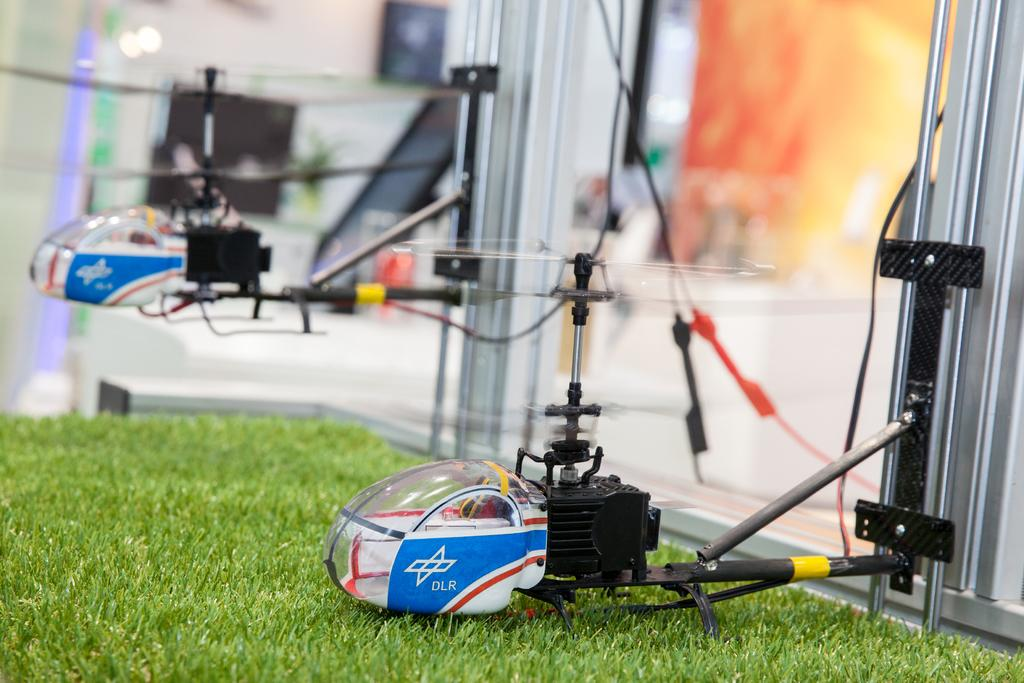What type of toy is present in the image? There are two toy helicopters in the image. What else can be seen in the image besides the toy helicopters? There is a glass visible in the image. Are there any other items in the image that are not clearly visible? Yes, there are blurred items visible in the image. Can you see any worms crawling on the toy helicopters in the image? No, there are no worms visible in the image. 